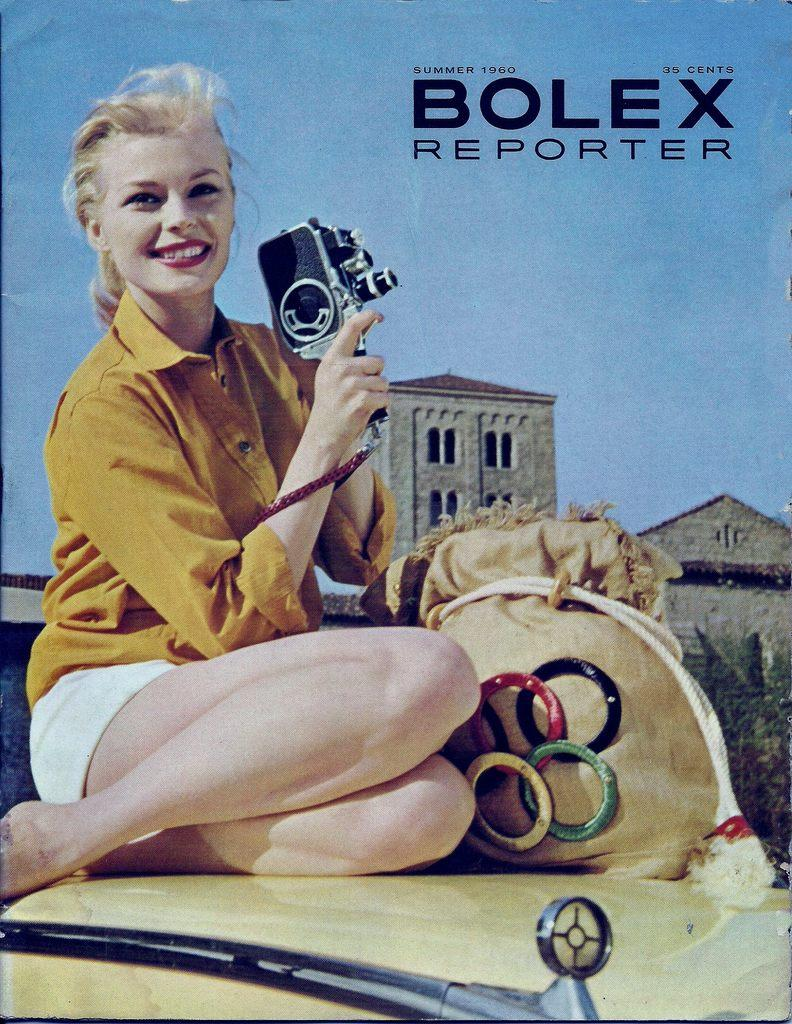What is depicted on the poster in the image? There is a poster in the image, and it features a woman. What is the woman wearing in the poster? The woman is wearing a yellow shirt in the poster. What is the woman doing in the poster? The woman is sitting on a car and giving a pose in the poster. What object is the woman holding in the poster? The woman is holding a black color camera in the poster. What can be seen in the background of the poster? There are old buildings visible in the background of the poster. What type of blade is the woman using to cut the cake in the image? There is no cake or blade present in the image; the woman is holding a camera and posing on a car. Can you tell me how the wind is affecting the woman's hair in the image? There is no indication of wind affecting the woman's hair in the image; her hair appears to be styled and not affected by any external factors. 